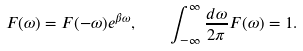<formula> <loc_0><loc_0><loc_500><loc_500>F ( \omega ) = F ( - \omega ) e ^ { \beta \omega } , \quad \int _ { - \infty } ^ { \infty } \frac { d \omega } { 2 \pi } F ( \omega ) = 1 .</formula> 